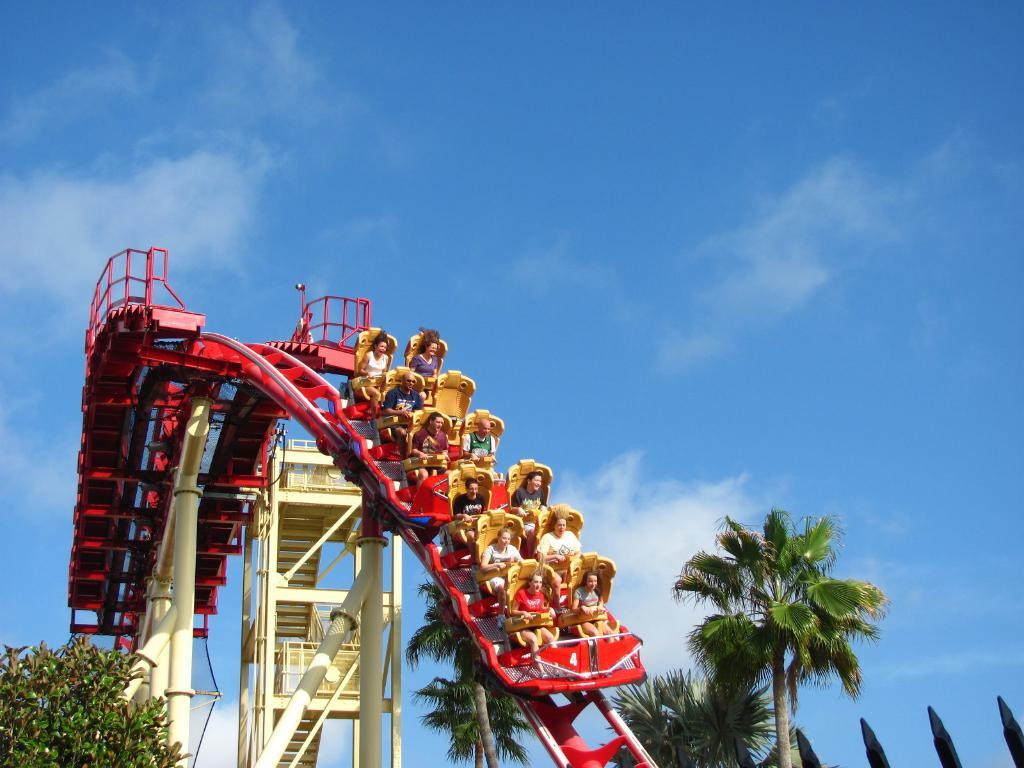What are the persons in the image doing? The persons in the image are on an amusing ride. What type of natural elements can be seen in the image? There are trees in the image. What structures are present in the image? There are poles in the image. What is visible in the background of the image? The sky is visible in the background, and clouds are present in the sky. What type of headwear is visible on the persons in the image? There is no mention of headwear in the image, so it cannot be determined from the facts provided. 